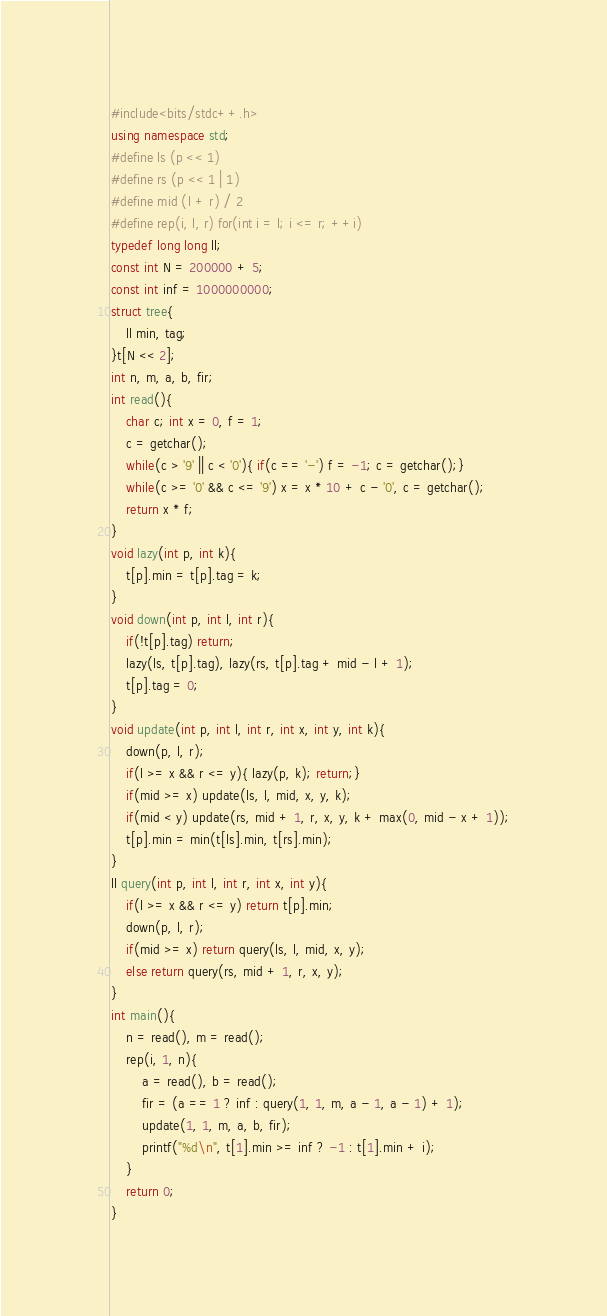Convert code to text. <code><loc_0><loc_0><loc_500><loc_500><_C++_>#include<bits/stdc++.h>
using namespace std;
#define ls (p << 1)
#define rs (p << 1 | 1)
#define mid (l + r) / 2
#define rep(i, l, r) for(int i = l; i <= r; ++i)
typedef long long ll;
const int N = 200000 + 5;
const int inf = 1000000000;
struct tree{
    ll min, tag;
}t[N << 2];
int n, m, a, b, fir;
int read(){
    char c; int x = 0, f = 1;
    c = getchar();
    while(c > '9' || c < '0'){ if(c == '-') f = -1; c = getchar();}
    while(c >= '0' && c <= '9') x = x * 10 + c - '0', c = getchar();
    return x * f;
}
void lazy(int p, int k){
    t[p].min = t[p].tag = k;
}
void down(int p, int l, int r){
    if(!t[p].tag) return;
    lazy(ls, t[p].tag), lazy(rs, t[p].tag + mid - l + 1);
    t[p].tag = 0;
}
void update(int p, int l, int r, int x, int y, int k){
    down(p, l, r);
    if(l >= x && r <= y){ lazy(p, k); return;}
    if(mid >= x) update(ls, l, mid, x, y, k);
    if(mid < y) update(rs, mid + 1, r, x, y, k + max(0, mid - x + 1));
    t[p].min = min(t[ls].min, t[rs].min);
}
ll query(int p, int l, int r, int x, int y){
    if(l >= x && r <= y) return t[p].min;
    down(p, l, r);
    if(mid >= x) return query(ls, l, mid, x, y);
    else return query(rs, mid + 1, r, x, y);
}
int main(){
    n = read(), m = read();
    rep(i, 1, n){
        a = read(), b = read();
        fir = (a == 1 ? inf : query(1, 1, m, a - 1, a - 1) + 1);
        update(1, 1, m, a, b, fir);
        printf("%d\n", t[1].min >= inf ? -1 : t[1].min + i);
    }
    return 0;
}</code> 